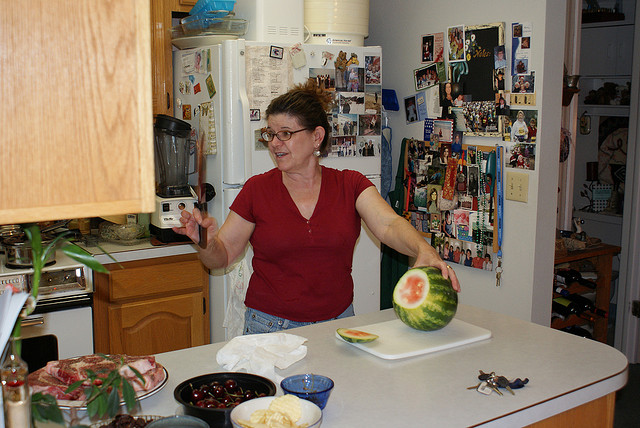What is the person doing in the image? The person in the image appears to be in the midst of preparing food, likely in a home kitchen environment. She's caught in an animated pose, possibly tossing a piece of watermelon, reflecting a moment of playfulness or demonstrating a cooking technique. 